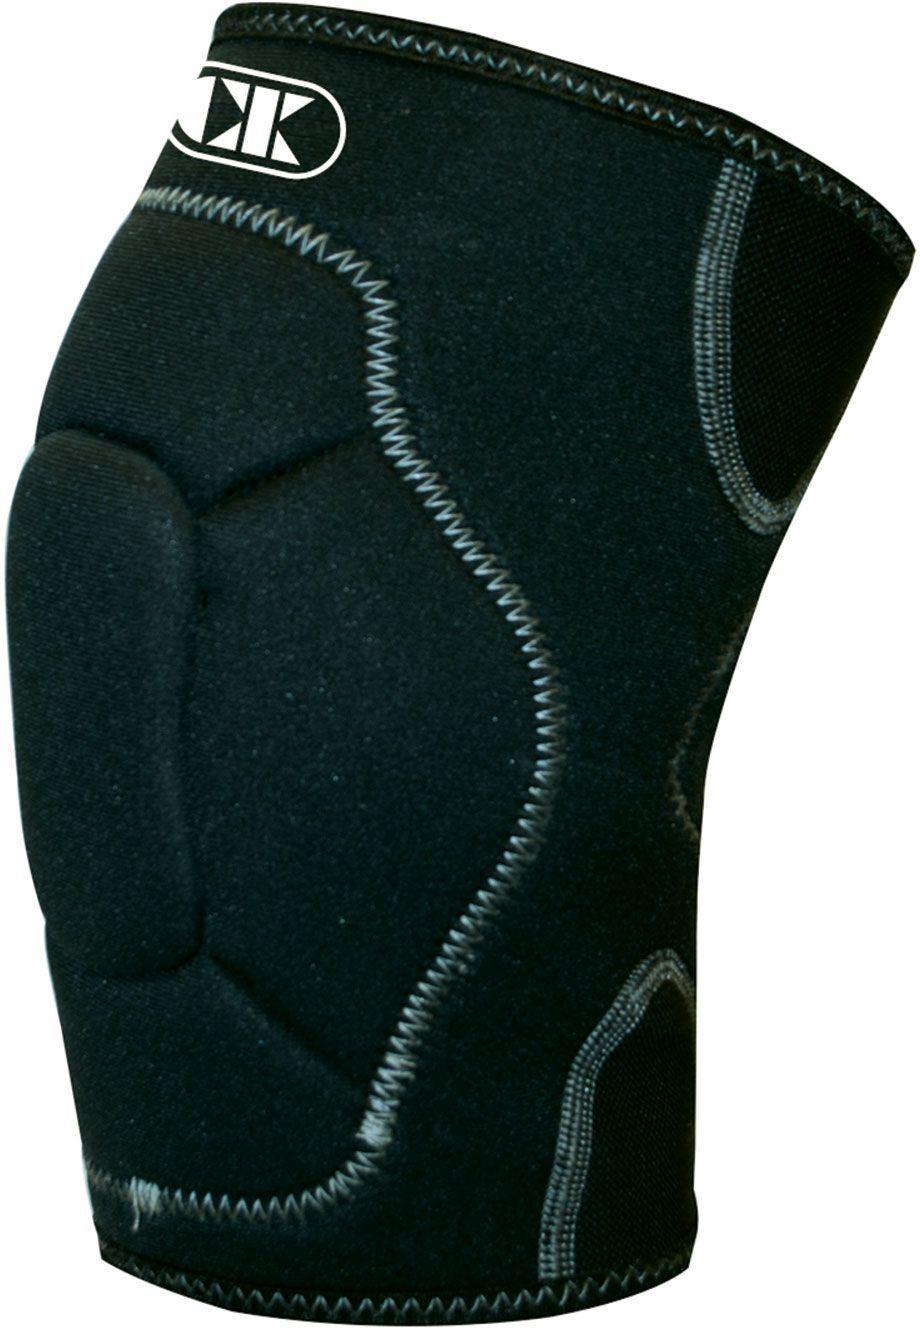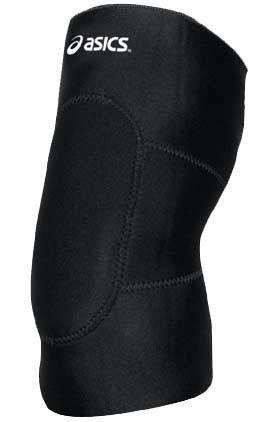The first image is the image on the left, the second image is the image on the right. Given the left and right images, does the statement "The item in the image on the left is facing forward." hold true? Answer yes or no. No. 